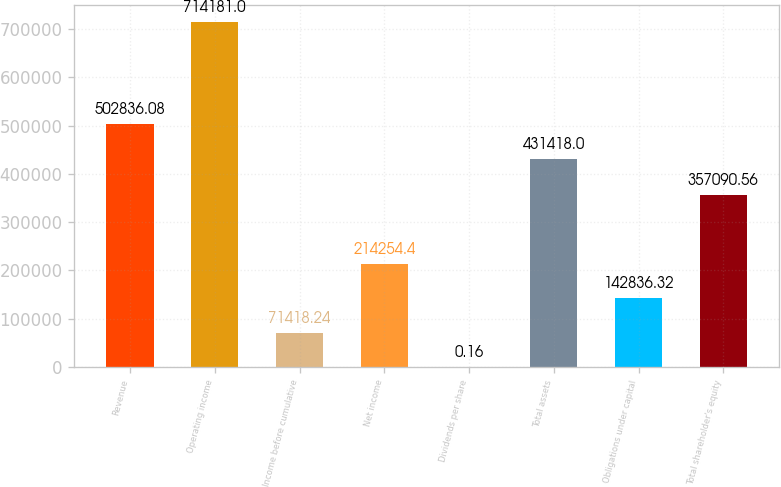Convert chart to OTSL. <chart><loc_0><loc_0><loc_500><loc_500><bar_chart><fcel>Revenue<fcel>Operating income<fcel>Income before cumulative<fcel>Net income<fcel>Dividends per share<fcel>Total assets<fcel>Obligations under capital<fcel>Total shareholder's equity<nl><fcel>502836<fcel>714181<fcel>71418.2<fcel>214254<fcel>0.16<fcel>431418<fcel>142836<fcel>357091<nl></chart> 